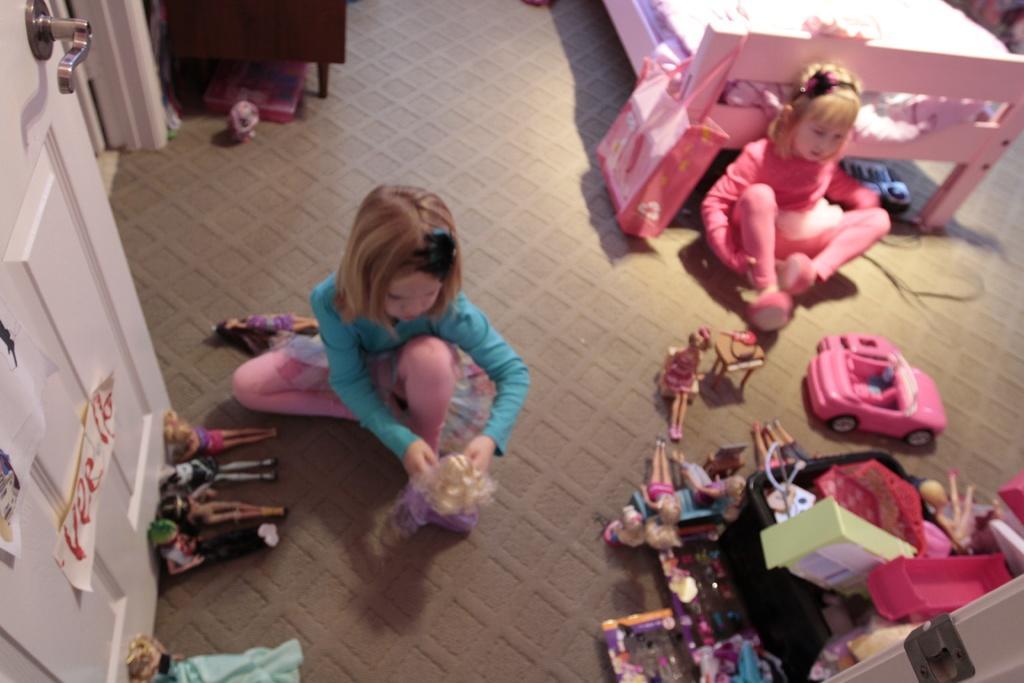Could you give a brief overview of what you see in this image? In the center of the image there is a girl holding a toy. In the bottom of the image there are many toys. There is a door. In the background of the image there is a bed. There is a girl. 